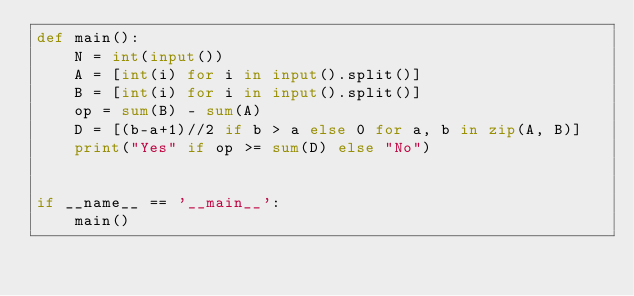<code> <loc_0><loc_0><loc_500><loc_500><_Python_>def main():
    N = int(input())
    A = [int(i) for i in input().split()]
    B = [int(i) for i in input().split()]
    op = sum(B) - sum(A)
    D = [(b-a+1)//2 if b > a else 0 for a, b in zip(A, B)]
    print("Yes" if op >= sum(D) else "No")


if __name__ == '__main__':
    main()
</code> 